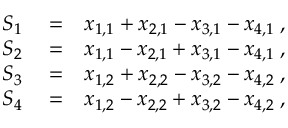<formula> <loc_0><loc_0><loc_500><loc_500>\begin{array} { r l r } { S _ { 1 } } & = } & { x _ { 1 , 1 } + x _ { 2 , 1 } - x _ { 3 , 1 } - x _ { 4 , 1 } \, , } \\ { S _ { 2 } } & = } & { x _ { 1 , 1 } - x _ { 2 , 1 } + x _ { 3 , 1 } - x _ { 4 , 1 } \, , } \\ { S _ { 3 } } & = } & { x _ { 1 , 2 } + x _ { 2 , 2 } - x _ { 3 , 2 } - x _ { 4 , 2 } \, , } \\ { S _ { 4 } } & = } & { x _ { 1 , 2 } - x _ { 2 , 2 } + x _ { 3 , 2 } - x _ { 4 , 2 } \, , } \end{array}</formula> 